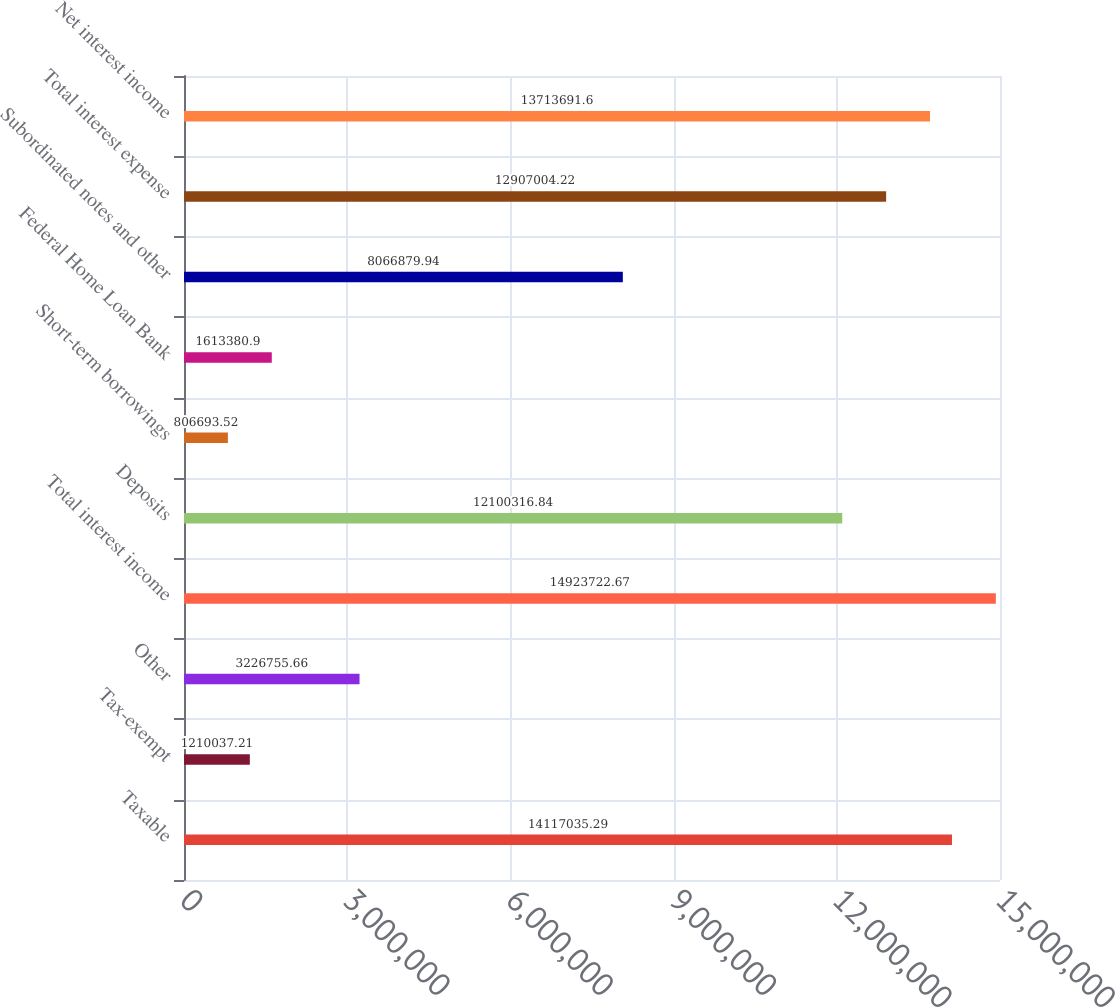<chart> <loc_0><loc_0><loc_500><loc_500><bar_chart><fcel>Taxable<fcel>Tax-exempt<fcel>Other<fcel>Total interest income<fcel>Deposits<fcel>Short-term borrowings<fcel>Federal Home Loan Bank<fcel>Subordinated notes and other<fcel>Total interest expense<fcel>Net interest income<nl><fcel>1.4117e+07<fcel>1.21004e+06<fcel>3.22676e+06<fcel>1.49237e+07<fcel>1.21003e+07<fcel>806694<fcel>1.61338e+06<fcel>8.06688e+06<fcel>1.2907e+07<fcel>1.37137e+07<nl></chart> 